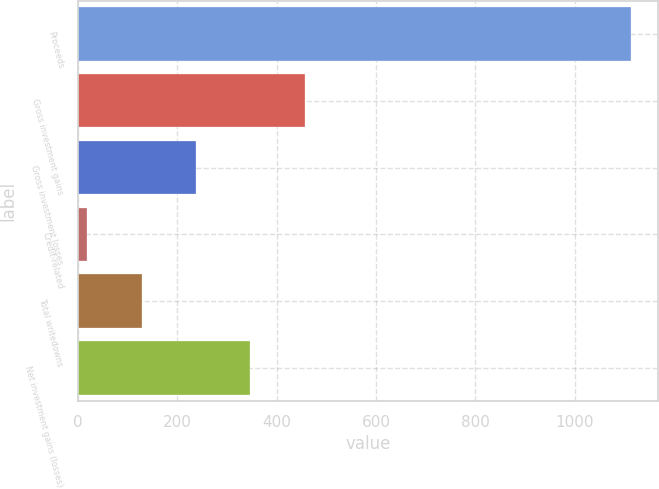<chart> <loc_0><loc_0><loc_500><loc_500><bar_chart><fcel>Proceeds<fcel>Gross investment gains<fcel>Gross investment losses<fcel>Credit-related<fcel>Total writedowns<fcel>Net investment gains (losses)<nl><fcel>1112<fcel>456.2<fcel>237.6<fcel>19<fcel>128.3<fcel>346.9<nl></chart> 